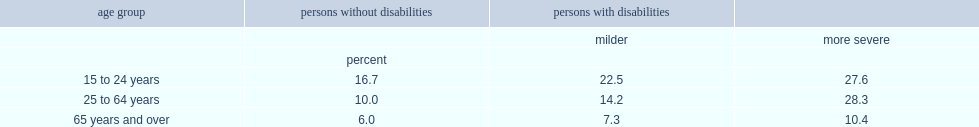Which type of disability was lesat likely to be living below canada's official poverty line for youth aged 15 to 24 years. Persons without disabilities. Which type of disability was lesat likely to be living below canada's official poverty line for working age adults? Persons without disabilities. How many times of low income for working age adults with more severe disabilities was that of working age adults with milder disabilities? 1.992958. What is the poverty rate of seniors with more severe disabilities? 10.4. Which level of disability was more likely to be living in poverty among seniors? More severe. How many times of poverty rate of seniors with more severe disabilities was that of working age adults? 0.367491. 